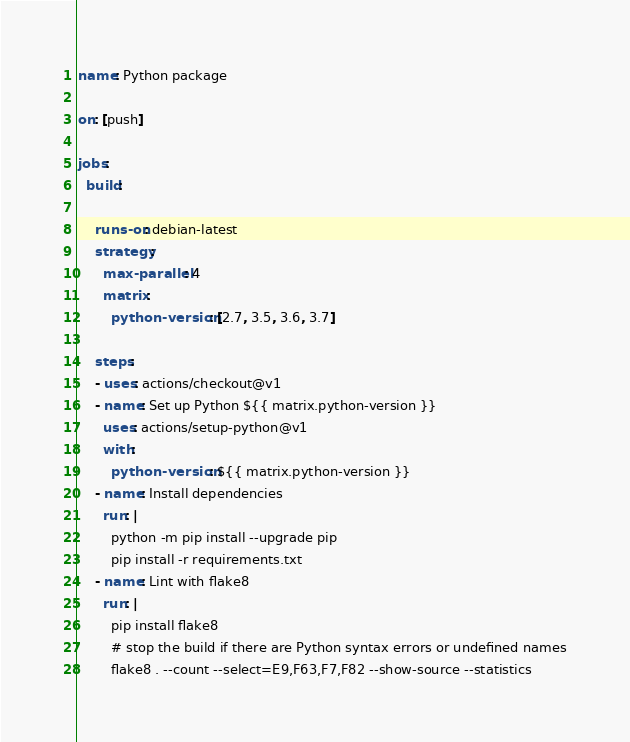<code> <loc_0><loc_0><loc_500><loc_500><_YAML_>name: Python package

on: [push]

jobs:
  build:

    runs-on: debian-latest
    strategy:
      max-parallel: 4
      matrix:
        python-version: [2.7, 3.5, 3.6, 3.7]

    steps:
    - uses: actions/checkout@v1
    - name: Set up Python ${{ matrix.python-version }}
      uses: actions/setup-python@v1
      with:
        python-version: ${{ matrix.python-version }}
    - name: Install dependencies
      run: |
        python -m pip install --upgrade pip
        pip install -r requirements.txt
    - name: Lint with flake8
      run: |
        pip install flake8
        # stop the build if there are Python syntax errors or undefined names
        flake8 . --count --select=E9,F63,F7,F82 --show-source --statistics</code> 